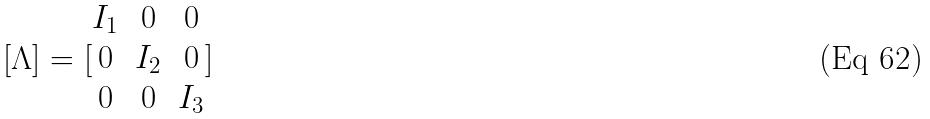Convert formula to latex. <formula><loc_0><loc_0><loc_500><loc_500>[ \Lambda ] = [ \begin{matrix} I _ { 1 } & 0 & 0 \\ 0 & I _ { 2 } & 0 \\ 0 & 0 & I _ { 3 } \end{matrix} ]</formula> 